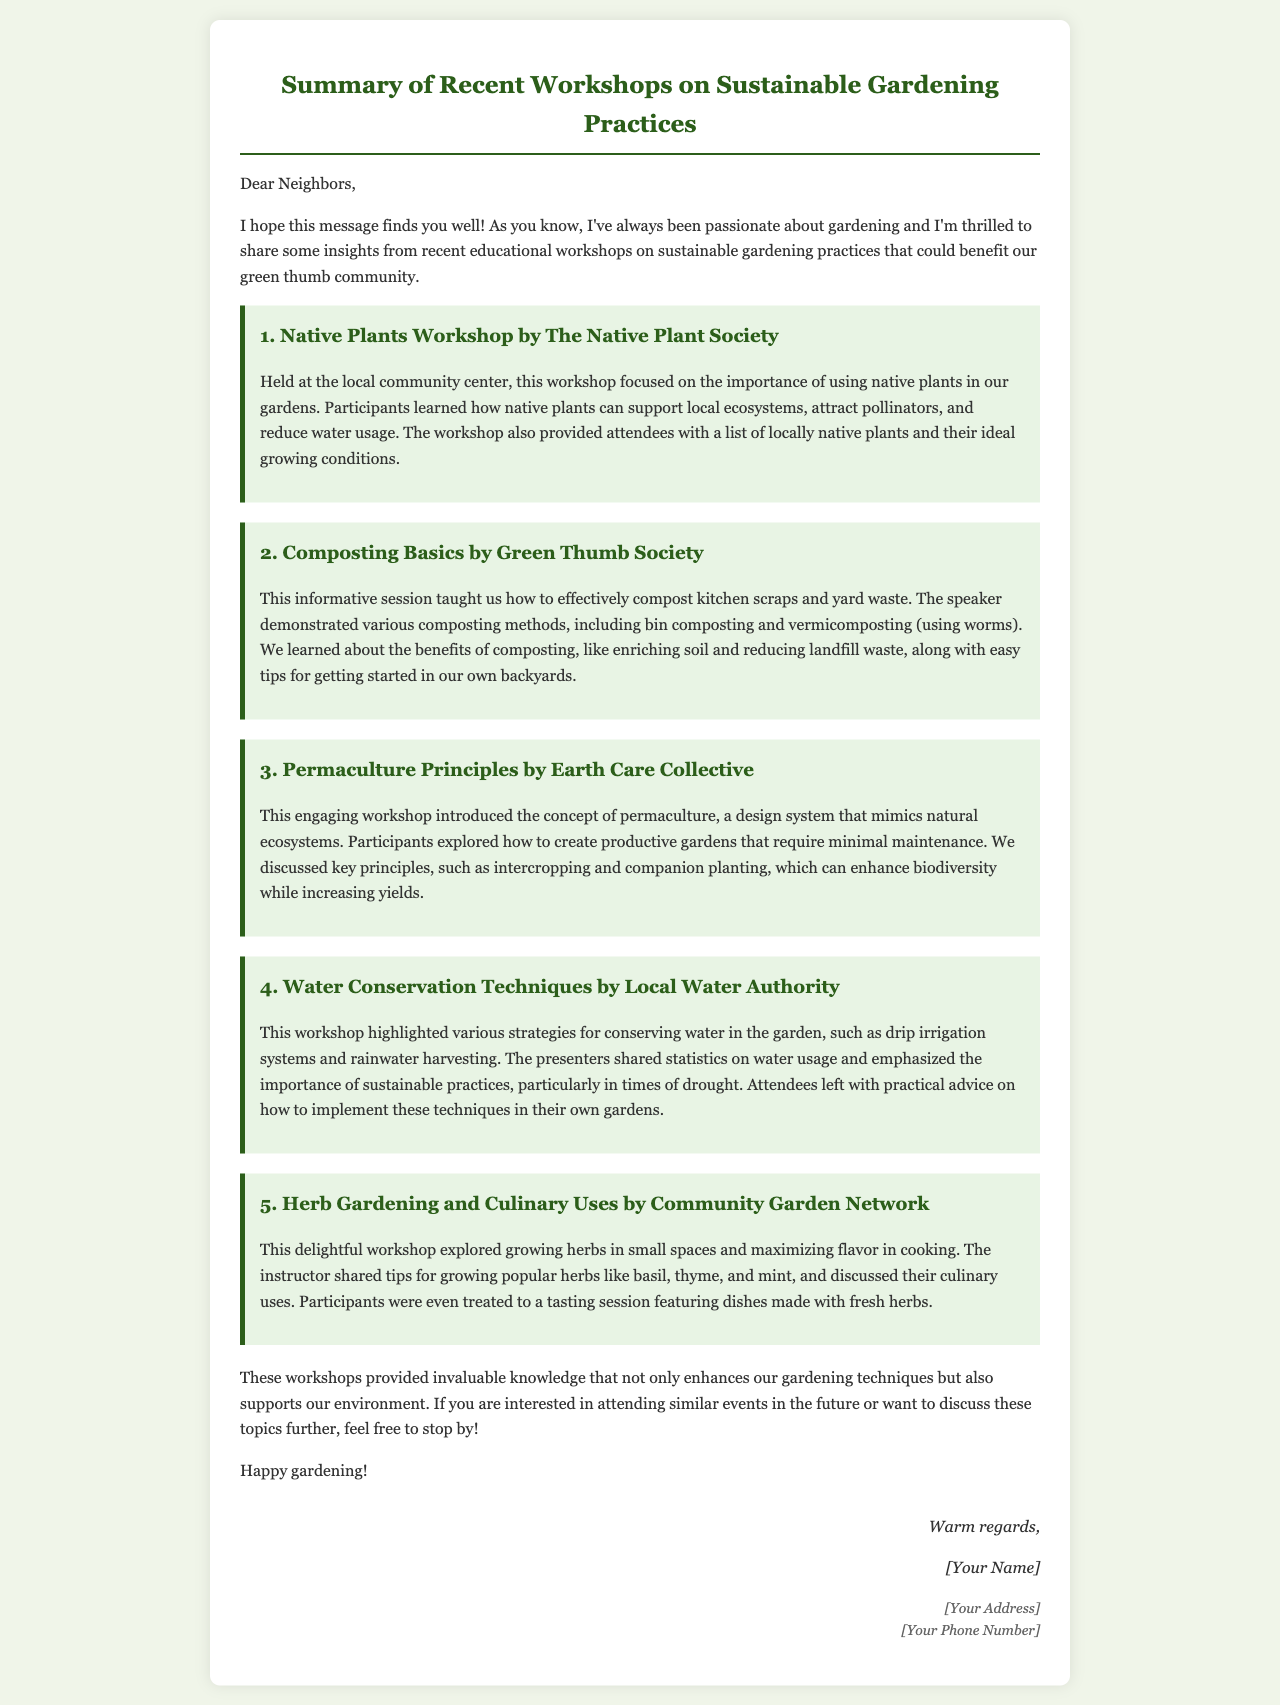What is the title of the email? The title is provided in the heading of the document, summarizing the content of the email.
Answer: Summary of Recent Workshops on Sustainable Gardening Practices Who hosted the Native Plants Workshop? The workshop is attributed to an organization known for its focus on native plants.
Answer: The Native Plant Society What is one benefit of composting mentioned in the email? The document highlights advantages of composting discussed during the workshop.
Answer: Enriching soil Which gardening concept was introduced by the Earth Care Collective? The email outlines different workshops, including one that introduced a specific gardening design system.
Answer: Permaculture What were participants treated to during the Herb Gardening workshop? The document mentions an activity that enhanced the learning experience at this particular workshop.
Answer: A tasting session How many workshops were summarized in the email? The email provides a list of workshops, which indicates the total number of sessions discussed.
Answer: Five 